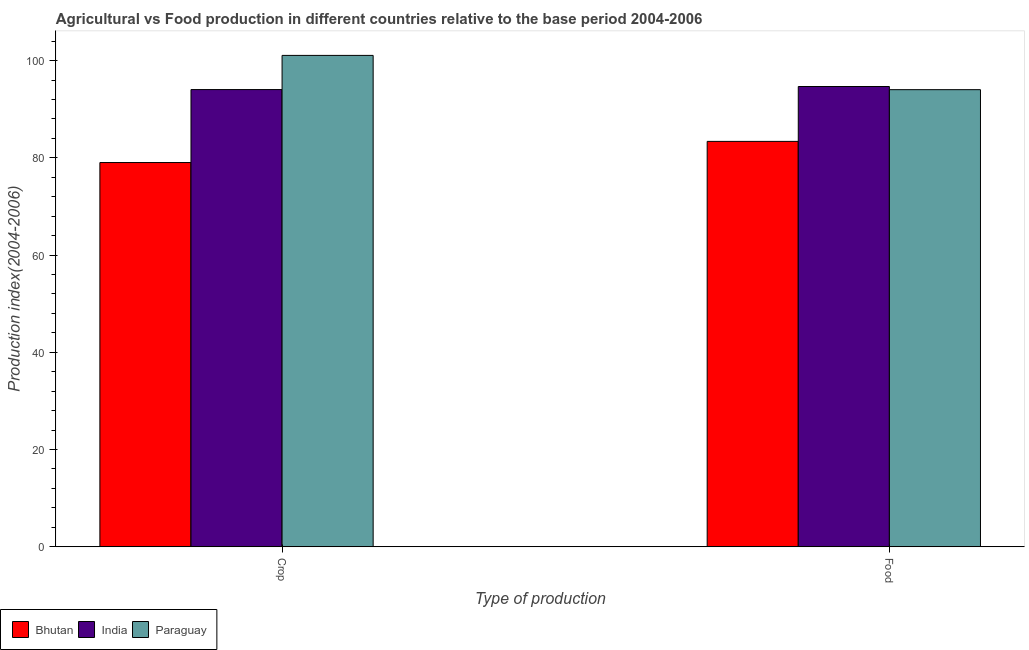How many groups of bars are there?
Your answer should be very brief. 2. Are the number of bars on each tick of the X-axis equal?
Give a very brief answer. Yes. How many bars are there on the 1st tick from the left?
Provide a succinct answer. 3. How many bars are there on the 2nd tick from the right?
Provide a short and direct response. 3. What is the label of the 1st group of bars from the left?
Ensure brevity in your answer.  Crop. What is the crop production index in Bhutan?
Make the answer very short. 79.04. Across all countries, what is the maximum crop production index?
Keep it short and to the point. 101.08. Across all countries, what is the minimum food production index?
Give a very brief answer. 83.39. In which country was the crop production index minimum?
Provide a succinct answer. Bhutan. What is the total crop production index in the graph?
Your response must be concise. 274.17. What is the difference between the food production index in Bhutan and that in India?
Give a very brief answer. -11.29. What is the difference between the crop production index in India and the food production index in Paraguay?
Your answer should be compact. 0.02. What is the average food production index per country?
Give a very brief answer. 90.7. What is the difference between the crop production index and food production index in India?
Your answer should be compact. -0.63. What is the ratio of the crop production index in Bhutan to that in Paraguay?
Ensure brevity in your answer.  0.78. Is the food production index in Paraguay less than that in Bhutan?
Keep it short and to the point. No. What does the 3rd bar from the right in Crop represents?
Your response must be concise. Bhutan. How many bars are there?
Provide a short and direct response. 6. How many countries are there in the graph?
Your response must be concise. 3. Are the values on the major ticks of Y-axis written in scientific E-notation?
Offer a terse response. No. Does the graph contain any zero values?
Provide a short and direct response. No. Does the graph contain grids?
Your answer should be compact. No. How many legend labels are there?
Offer a very short reply. 3. What is the title of the graph?
Your answer should be compact. Agricultural vs Food production in different countries relative to the base period 2004-2006. Does "Estonia" appear as one of the legend labels in the graph?
Keep it short and to the point. No. What is the label or title of the X-axis?
Your response must be concise. Type of production. What is the label or title of the Y-axis?
Keep it short and to the point. Production index(2004-2006). What is the Production index(2004-2006) in Bhutan in Crop?
Keep it short and to the point. 79.04. What is the Production index(2004-2006) in India in Crop?
Offer a terse response. 94.05. What is the Production index(2004-2006) in Paraguay in Crop?
Give a very brief answer. 101.08. What is the Production index(2004-2006) of Bhutan in Food?
Provide a succinct answer. 83.39. What is the Production index(2004-2006) in India in Food?
Your answer should be compact. 94.68. What is the Production index(2004-2006) of Paraguay in Food?
Your response must be concise. 94.03. Across all Type of production, what is the maximum Production index(2004-2006) of Bhutan?
Your answer should be very brief. 83.39. Across all Type of production, what is the maximum Production index(2004-2006) in India?
Your answer should be compact. 94.68. Across all Type of production, what is the maximum Production index(2004-2006) of Paraguay?
Offer a terse response. 101.08. Across all Type of production, what is the minimum Production index(2004-2006) in Bhutan?
Provide a succinct answer. 79.04. Across all Type of production, what is the minimum Production index(2004-2006) of India?
Ensure brevity in your answer.  94.05. Across all Type of production, what is the minimum Production index(2004-2006) of Paraguay?
Give a very brief answer. 94.03. What is the total Production index(2004-2006) in Bhutan in the graph?
Make the answer very short. 162.43. What is the total Production index(2004-2006) in India in the graph?
Offer a very short reply. 188.73. What is the total Production index(2004-2006) of Paraguay in the graph?
Your answer should be compact. 195.11. What is the difference between the Production index(2004-2006) in Bhutan in Crop and that in Food?
Provide a succinct answer. -4.35. What is the difference between the Production index(2004-2006) in India in Crop and that in Food?
Keep it short and to the point. -0.63. What is the difference between the Production index(2004-2006) of Paraguay in Crop and that in Food?
Give a very brief answer. 7.05. What is the difference between the Production index(2004-2006) of Bhutan in Crop and the Production index(2004-2006) of India in Food?
Provide a succinct answer. -15.64. What is the difference between the Production index(2004-2006) in Bhutan in Crop and the Production index(2004-2006) in Paraguay in Food?
Offer a terse response. -14.99. What is the difference between the Production index(2004-2006) in India in Crop and the Production index(2004-2006) in Paraguay in Food?
Give a very brief answer. 0.02. What is the average Production index(2004-2006) in Bhutan per Type of production?
Keep it short and to the point. 81.22. What is the average Production index(2004-2006) in India per Type of production?
Ensure brevity in your answer.  94.36. What is the average Production index(2004-2006) in Paraguay per Type of production?
Offer a terse response. 97.56. What is the difference between the Production index(2004-2006) in Bhutan and Production index(2004-2006) in India in Crop?
Give a very brief answer. -15.01. What is the difference between the Production index(2004-2006) of Bhutan and Production index(2004-2006) of Paraguay in Crop?
Provide a short and direct response. -22.04. What is the difference between the Production index(2004-2006) of India and Production index(2004-2006) of Paraguay in Crop?
Offer a very short reply. -7.03. What is the difference between the Production index(2004-2006) of Bhutan and Production index(2004-2006) of India in Food?
Your answer should be very brief. -11.29. What is the difference between the Production index(2004-2006) of Bhutan and Production index(2004-2006) of Paraguay in Food?
Provide a succinct answer. -10.64. What is the difference between the Production index(2004-2006) in India and Production index(2004-2006) in Paraguay in Food?
Give a very brief answer. 0.65. What is the ratio of the Production index(2004-2006) of Bhutan in Crop to that in Food?
Provide a short and direct response. 0.95. What is the ratio of the Production index(2004-2006) in India in Crop to that in Food?
Ensure brevity in your answer.  0.99. What is the ratio of the Production index(2004-2006) in Paraguay in Crop to that in Food?
Your answer should be very brief. 1.07. What is the difference between the highest and the second highest Production index(2004-2006) of Bhutan?
Give a very brief answer. 4.35. What is the difference between the highest and the second highest Production index(2004-2006) in India?
Your answer should be very brief. 0.63. What is the difference between the highest and the second highest Production index(2004-2006) in Paraguay?
Give a very brief answer. 7.05. What is the difference between the highest and the lowest Production index(2004-2006) of Bhutan?
Provide a short and direct response. 4.35. What is the difference between the highest and the lowest Production index(2004-2006) in India?
Offer a very short reply. 0.63. What is the difference between the highest and the lowest Production index(2004-2006) of Paraguay?
Your answer should be compact. 7.05. 